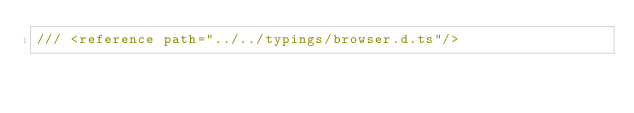<code> <loc_0><loc_0><loc_500><loc_500><_TypeScript_>/// <reference path="../../typings/browser.d.ts"/></code> 